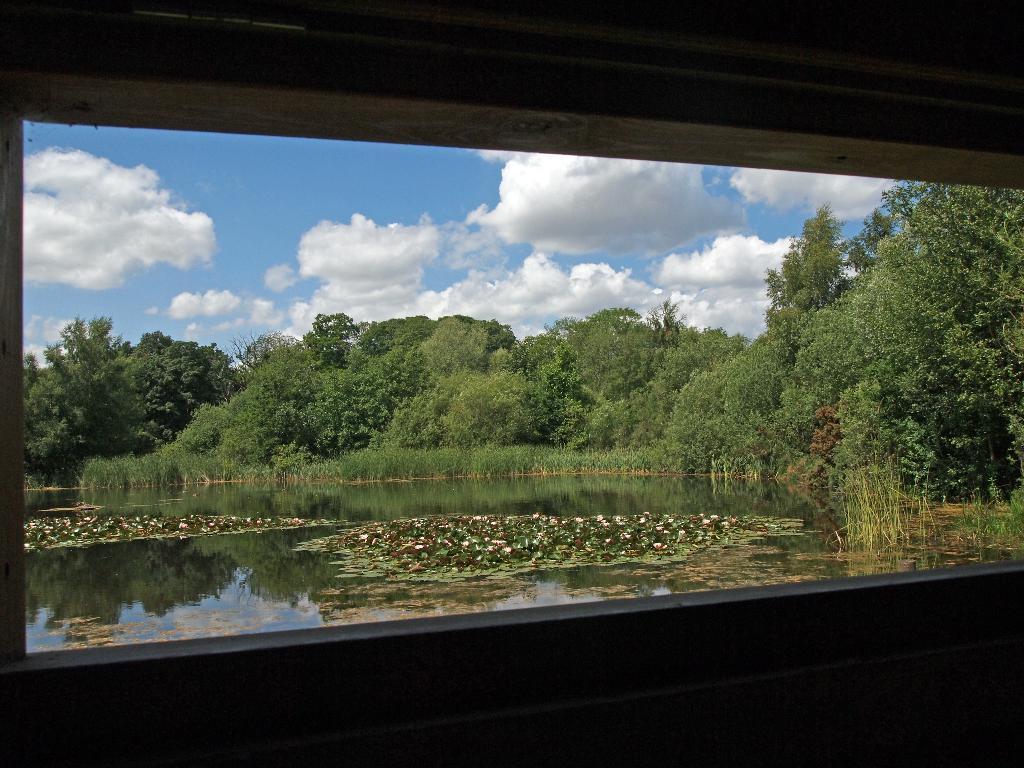How would you summarize this image in a sentence or two? Through the window we can see the sky with clouds, trees and water. On the water we can see the flowers and leaves. 